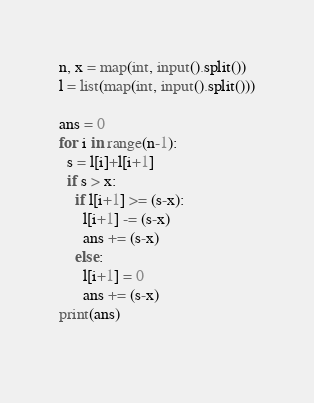Convert code to text. <code><loc_0><loc_0><loc_500><loc_500><_Python_>n, x = map(int, input().split())
l = list(map(int, input().split()))

ans = 0
for i in range(n-1):
  s = l[i]+l[i+1]
  if s > x:
    if l[i+1] >= (s-x):
      l[i+1] -= (s-x)
      ans += (s-x)
    else:
      l[i+1] = 0
      ans += (s-x)
print(ans)
  </code> 